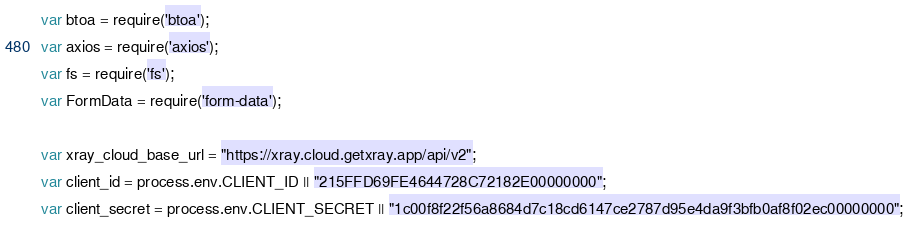<code> <loc_0><loc_0><loc_500><loc_500><_JavaScript_>var btoa = require('btoa');
var axios = require('axios');
var fs = require('fs');
var FormData = require('form-data');

var xray_cloud_base_url = "https://xray.cloud.getxray.app/api/v2";
var client_id = process.env.CLIENT_ID || "215FFD69FE4644728C72182E00000000";
var client_secret = process.env.CLIENT_SECRET || "1c00f8f22f56a8684d7c18cd6147ce2787d95e4da9f3bfb0af8f02ec00000000";
</code> 